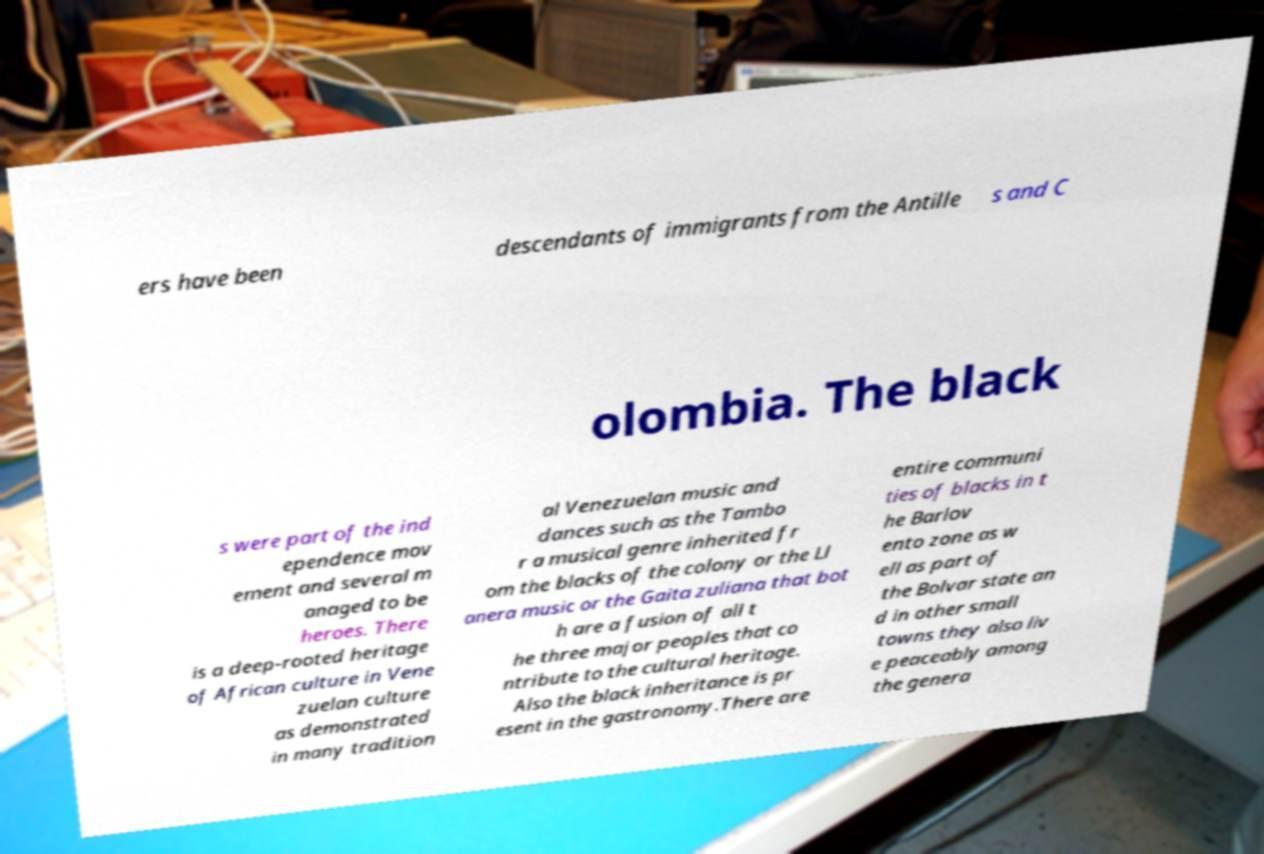For documentation purposes, I need the text within this image transcribed. Could you provide that? ers have been descendants of immigrants from the Antille s and C olombia. The black s were part of the ind ependence mov ement and several m anaged to be heroes. There is a deep-rooted heritage of African culture in Vene zuelan culture as demonstrated in many tradition al Venezuelan music and dances such as the Tambo r a musical genre inherited fr om the blacks of the colony or the Ll anera music or the Gaita zuliana that bot h are a fusion of all t he three major peoples that co ntribute to the cultural heritage. Also the black inheritance is pr esent in the gastronomy.There are entire communi ties of blacks in t he Barlov ento zone as w ell as part of the Bolvar state an d in other small towns they also liv e peaceably among the genera 